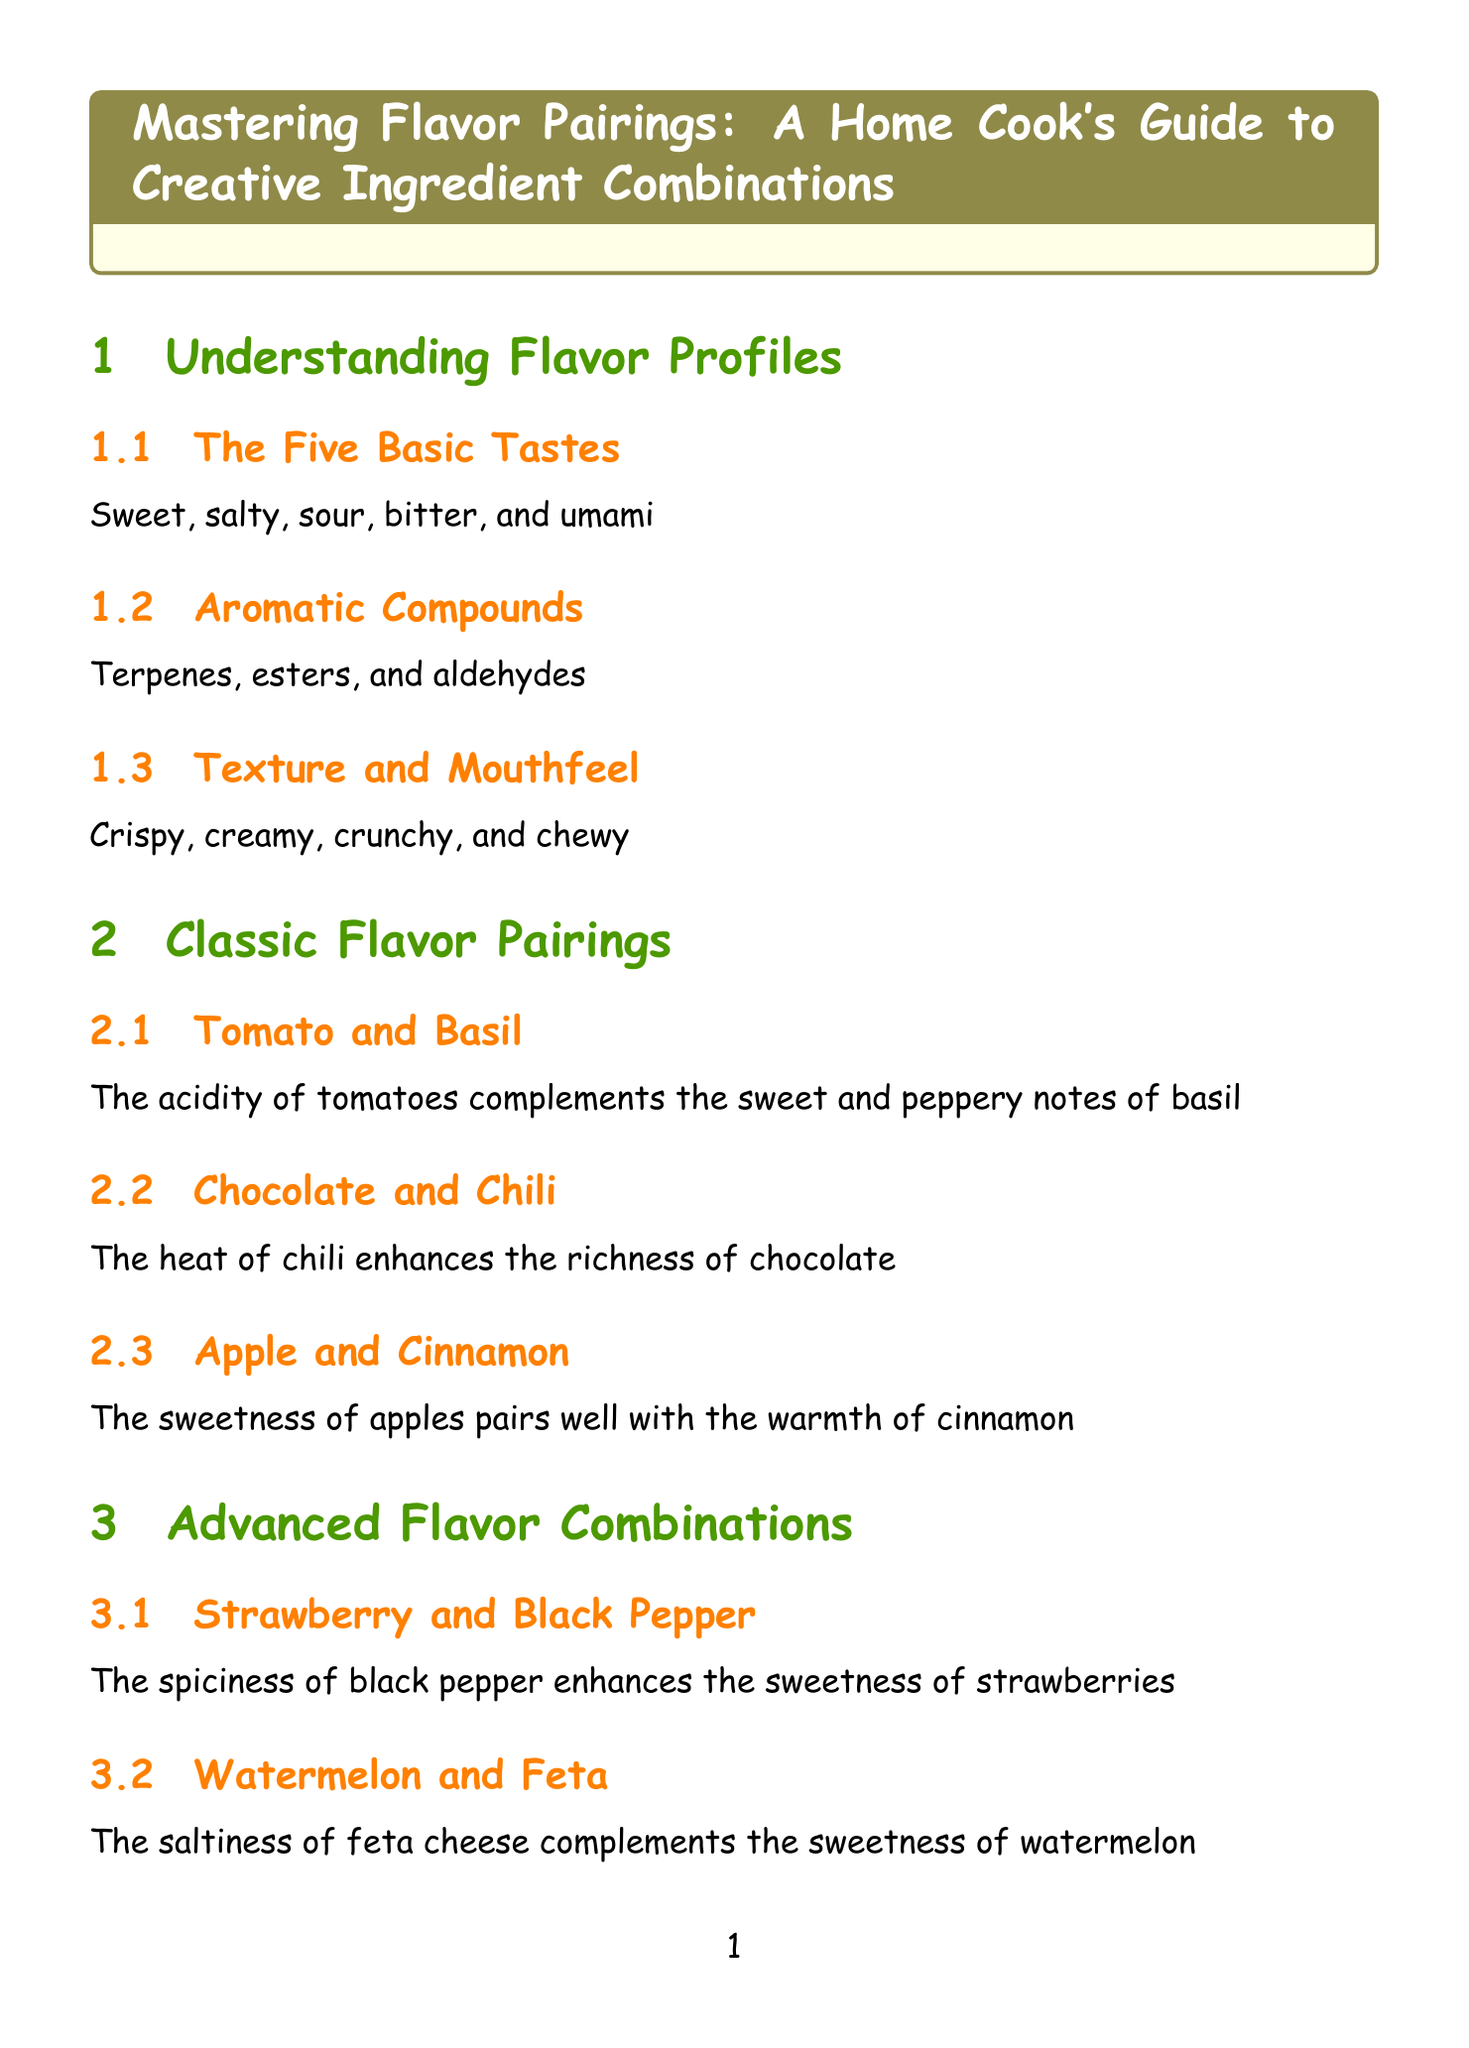What are the five basic tastes? The five basic tastes listed in the document are fundamental to flavor profiles, detailing the basic sensations we perceive.
Answer: Sweet, salty, sour, bitter, and umami What pairs well with Chocolate in classic pairings? The classic pairing mentioned in the document highlights a specific ingredient that complements chocolate's flavor.
Answer: Chili What is a primary flavor used in Mediterranean cuisine? The document identifies a variety of ingredients typical to virtual cuisines, and this specific section covers Mediterranean flavors.
Answer: Olive oil Which two ingredients pair in autumn seasonal pairings? This particular seasonal combination is defined to highlight specific ingredients that are best together during autumn.
Answer: Pumpkin and sage What technique involves tasting ingredients separately? The document specifies a method that focuses on assessing components of flavor through individual tasting experiences.
Answer: Sensory Analysis What is the focus of Fusion Cuisine? The document succinctly describes a culinary approach that combines different tradition's flavors and methods.
Answer: Combining flavors and techniques from different culinary traditions What is a recommended non-alcoholic pairing for Asian-inspired dishes? The document suggests a specific beverage that complements the flavors of Asian cuisine for those who prefer non-alcoholic options.
Answer: Kombucha Which ingredient enhances the depth of flavor as an umami booster? This section in the document points out particular ingredients that elevate the savory aspects of dishes.
Answer: Mushrooms What pairing combines strawberry with a spice? The document features a unique flavor combination highlighting a fruit paired with a specific seasoning.
Answer: Black Pepper 